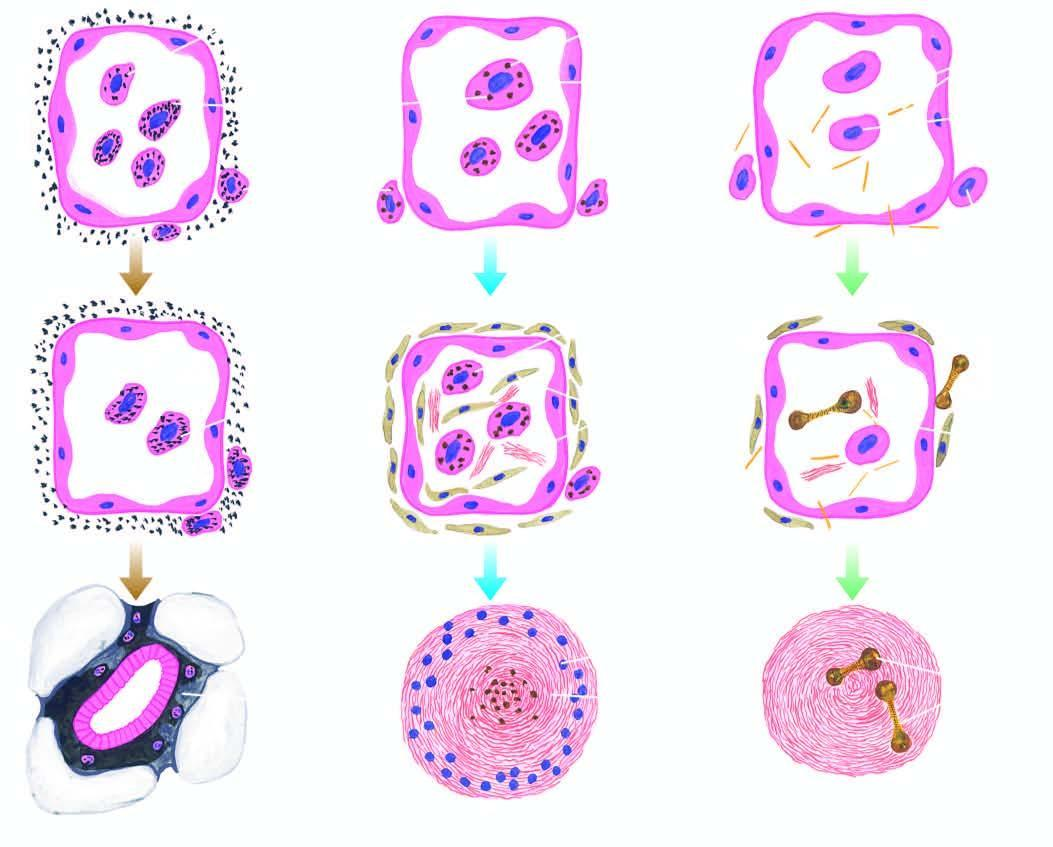what are toxic to macrophages?
Answer the question using a single word or phrase. Tiny silica particles 